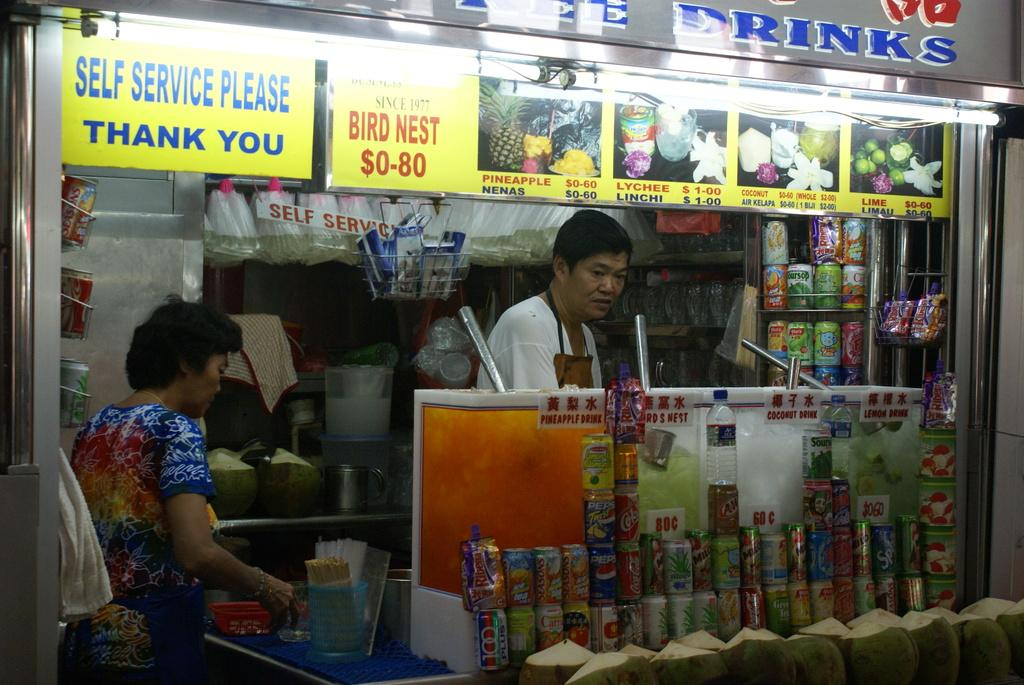<image>
Provide a brief description of the given image. Two people are behind the counter at a store under the sign for Self Service Thank You. 